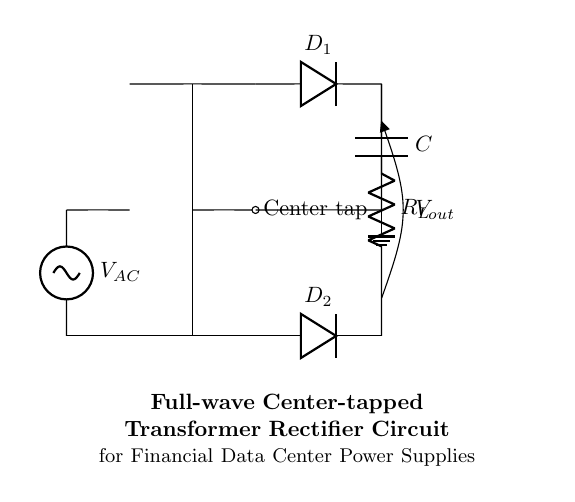What is the type of this rectifier circuit? The circuit is a full-wave rectifier based on the arrangement of components, particularly the center-tapped transformer and the two diodes used to convert AC to DC.
Answer: full-wave rectifier How many diodes are used in this circuit? There are two diodes present in the circuit, labeled as D1 and D2, which are responsible for the rectification process in both halves of the AC cycle.
Answer: 2 What is the role of the load resistor? The load resistor, labeled R_L, represents the component that consumes the power generated by the rectified output, making it essential for defining the circuit's load characteristics.
Answer: power consumption What does the output capacitor do in this circuit? The output capacitor, labeled C, smooths the output voltage by filtering out fluctuations caused by the rectification process, providing a more stable DC output to the load.
Answer: smooth the output voltage Where is the center tap located? The center tap is indicated by a label on the circuit diagram and is a connection point at the transformer that enables the use of both halves of the AC waveform for rectification.
Answer: at the transformer What is the purpose of the transformer in this circuit? The transformer steps up or steps down the input voltage from the AC source, ensuring that the output voltage after rectification is at the desired level relative to the load requirements.
Answer: voltage adjustment What does the term "Vout" represent in the diagram? The term Vout indicates the output voltage produced after rectification, which is the voltage across the load resistor R_L, delivering DC power to the connected load.
Answer: output voltage 